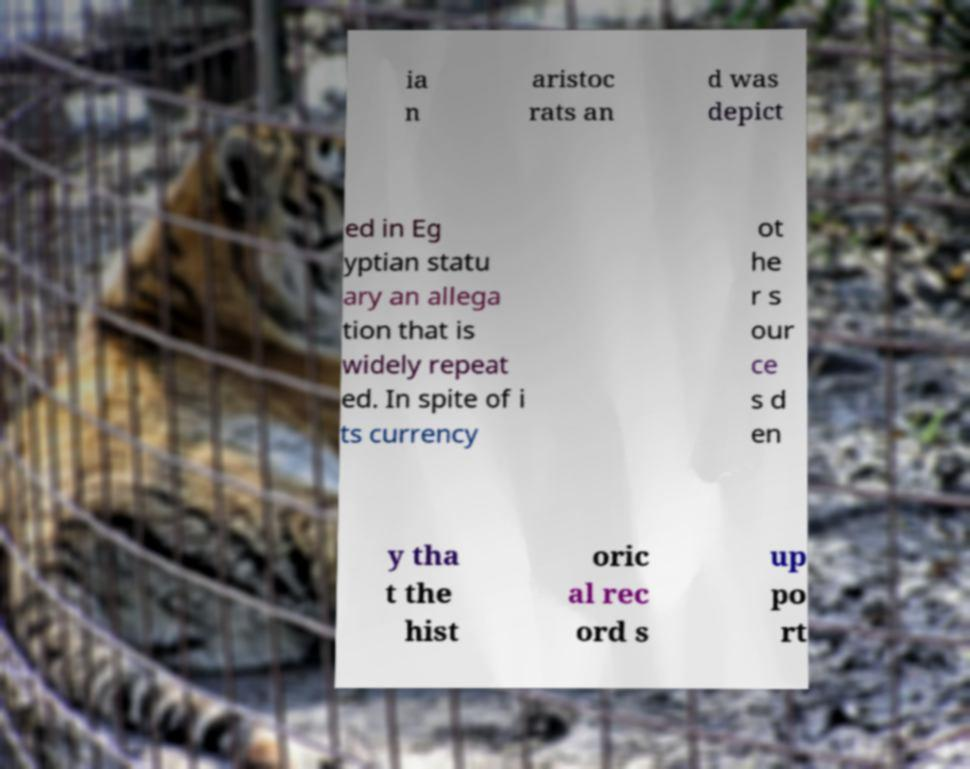Can you read and provide the text displayed in the image?This photo seems to have some interesting text. Can you extract and type it out for me? ia n aristoc rats an d was depict ed in Eg yptian statu ary an allega tion that is widely repeat ed. In spite of i ts currency ot he r s our ce s d en y tha t the hist oric al rec ord s up po rt 